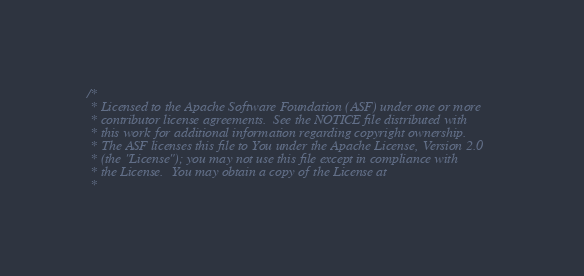<code> <loc_0><loc_0><loc_500><loc_500><_Scala_>/*
 * Licensed to the Apache Software Foundation (ASF) under one or more
 * contributor license agreements.  See the NOTICE file distributed with
 * this work for additional information regarding copyright ownership.
 * The ASF licenses this file to You under the Apache License, Version 2.0
 * (the "License"); you may not use this file except in compliance with
 * the License.  You may obtain a copy of the License at
 *</code> 